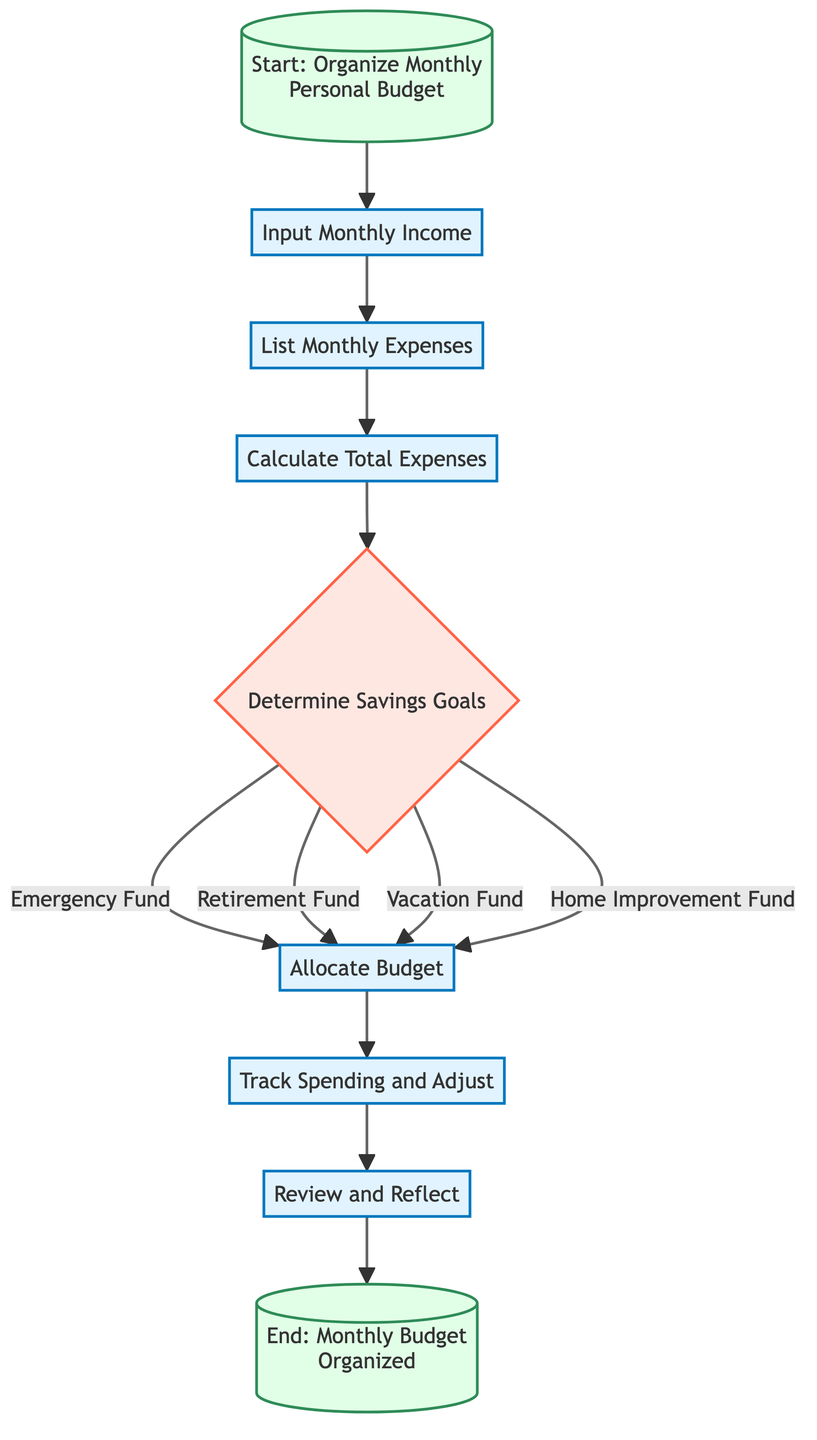What is the first step in the diagram? The first step in the diagram is "Input Monthly Income", which indicates that the process begins by entering the total monthly income from all sources.
Answer: Input Monthly Income How many savings goals are determined? The diagram lists four specific savings goals that need to be determined: Emergency Fund, Retirement Fund, Vacation Fund, and Home Improvement Fund, resulting in four savings goals.
Answer: Four What follows after "Calculate Total Expenses"? After "Calculate Total Expenses", the next step is "Determine Savings Goals", which indicates that the process moves into setting specific savings targets after calculating the total expenditure.
Answer: Determine Savings Goals What steps are involved in allocating the budget? The budget allocation involves subtracting total expenses and savings allocations from monthly income, which is indicated at the "Allocate Budget" step after the determination of savings goals.
Answer: Subtract total expenses and savings allocations from monthly income What is the final step in the process? The final step in the process is "End: Monthly Budget Organized", indicating the conclusion of the budgeting process following the review and reflection of the month.
Answer: End: Monthly Budget Organized How are the savings goals categorized? The savings goals are categorized into specific types: Emergency Fund, Retirement Fund, Vacation Fund, and Home Improvement Fund; each goal is identified within the decision node of the flowchart.
Answer: Specific types How does the process adjust based on actual spending? The process incorporates a step labeled "Track Spending and Adjust", where monitoring of actual spending against the budget occurs throughout the month, followed by necessary adjustments based on this tracking.
Answer: Monitor actual spending Which step directly precedes "Review and Reflect"? The step that directly precedes "Review and Reflect" is "Track Spending and Adjust", which indicates that after tracking expenditures throughout the month, a review of the budget and savings progress is done at the end.
Answer: Track Spending and Adjust 